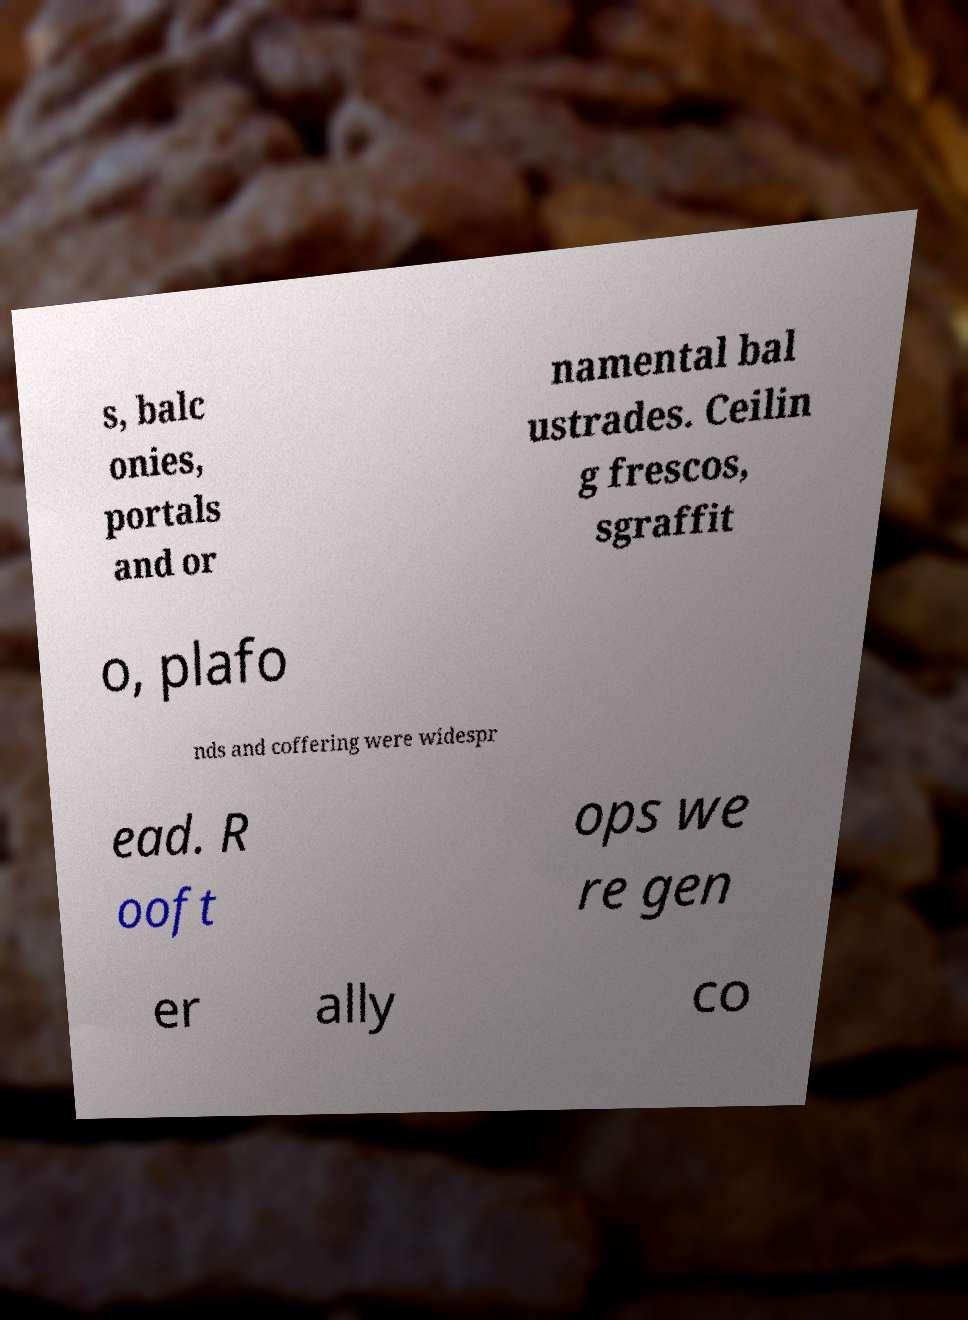Could you extract and type out the text from this image? s, balc onies, portals and or namental bal ustrades. Ceilin g frescos, sgraffit o, plafo nds and coffering were widespr ead. R ooft ops we re gen er ally co 